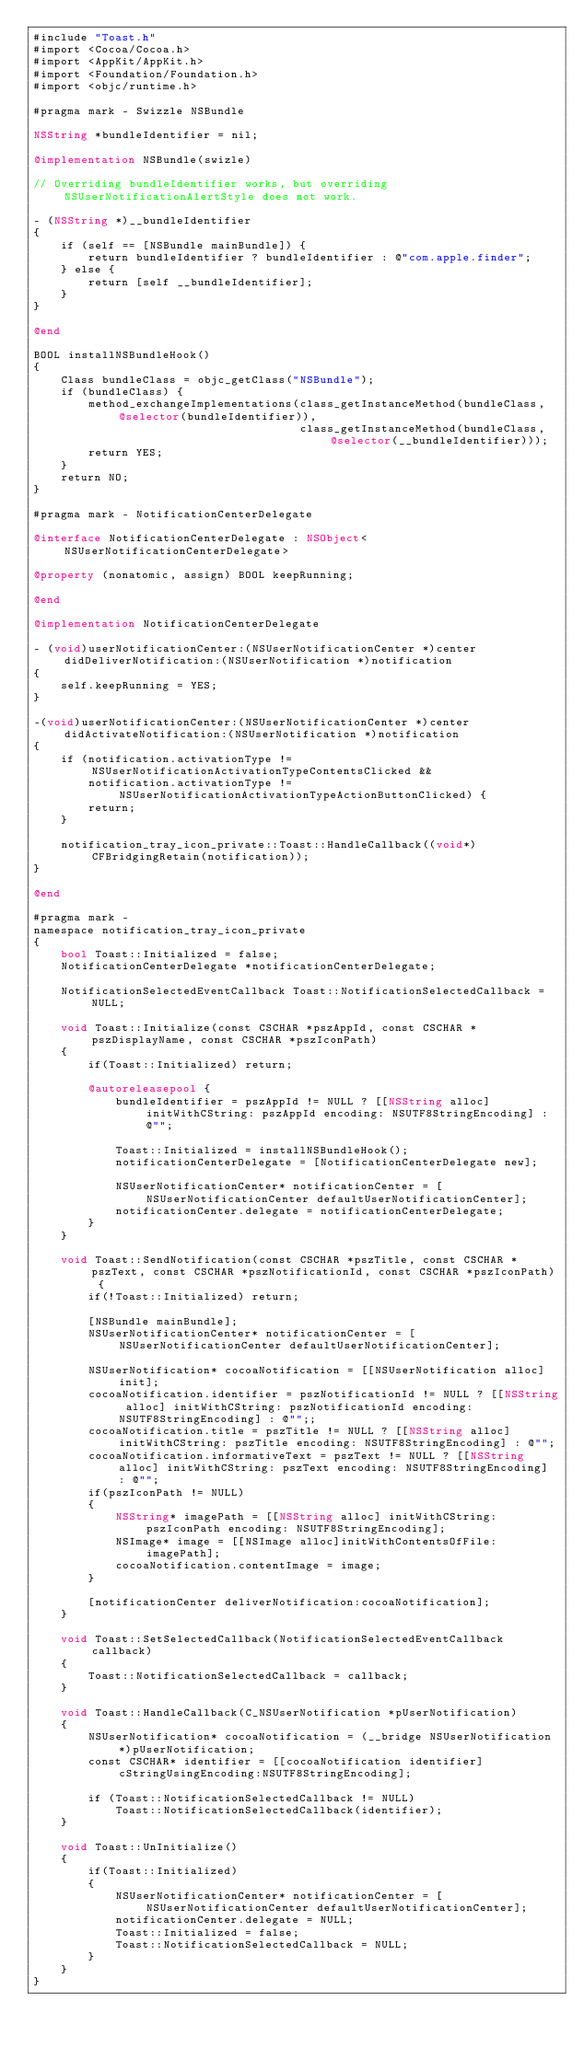Convert code to text. <code><loc_0><loc_0><loc_500><loc_500><_ObjectiveC_>#include "Toast.h"
#import <Cocoa/Cocoa.h>
#import <AppKit/AppKit.h>
#import <Foundation/Foundation.h>
#import <objc/runtime.h>

#pragma mark - Swizzle NSBundle

NSString *bundleIdentifier = nil; 

@implementation NSBundle(swizle)

// Overriding bundleIdentifier works, but overriding NSUserNotificationAlertStyle does not work.

- (NSString *)__bundleIdentifier
{
    if (self == [NSBundle mainBundle]) {
        return bundleIdentifier ? bundleIdentifier : @"com.apple.finder";
    } else {
        return [self __bundleIdentifier];
    }
}

@end

BOOL installNSBundleHook()
{
    Class bundleClass = objc_getClass("NSBundle");
    if (bundleClass) {
        method_exchangeImplementations(class_getInstanceMethod(bundleClass, @selector(bundleIdentifier)),
                                       class_getInstanceMethod(bundleClass, @selector(__bundleIdentifier)));
        return YES;
    }
    return NO;
}

#pragma mark - NotificationCenterDelegate

@interface NotificationCenterDelegate : NSObject<NSUserNotificationCenterDelegate>

@property (nonatomic, assign) BOOL keepRunning;

@end

@implementation NotificationCenterDelegate

- (void)userNotificationCenter:(NSUserNotificationCenter *)center didDeliverNotification:(NSUserNotification *)notification
{
    self.keepRunning = YES;
}

-(void)userNotificationCenter:(NSUserNotificationCenter *)center didActivateNotification:(NSUserNotification *)notification
{
    if (notification.activationType != NSUserNotificationActivationTypeContentsClicked &&
        notification.activationType != NSUserNotificationActivationTypeActionButtonClicked) {
        return;
    }

    notification_tray_icon_private::Toast::HandleCallback((void*)CFBridgingRetain(notification));
}

@end

#pragma mark -
namespace notification_tray_icon_private
{
    bool Toast::Initialized = false;
    NotificationCenterDelegate *notificationCenterDelegate;

    NotificationSelectedEventCallback Toast::NotificationSelectedCallback = NULL;

    void Toast::Initialize(const CSCHAR *pszAppId, const CSCHAR *pszDisplayName, const CSCHAR *pszIconPath)
    {
        if(Toast::Initialized) return;

        @autoreleasepool {
            bundleIdentifier = pszAppId != NULL ? [[NSString alloc] initWithCString: pszAppId encoding: NSUTF8StringEncoding] : @"";

            Toast::Initialized = installNSBundleHook();
            notificationCenterDelegate = [NotificationCenterDelegate new];

            NSUserNotificationCenter* notificationCenter = [NSUserNotificationCenter defaultUserNotificationCenter];
            notificationCenter.delegate = notificationCenterDelegate;
        }
    }

    void Toast::SendNotification(const CSCHAR *pszTitle, const CSCHAR *pszText, const CSCHAR *pszNotificationId, const CSCHAR *pszIconPath) {
        if(!Toast::Initialized) return;

        [NSBundle mainBundle];
        NSUserNotificationCenter* notificationCenter = [NSUserNotificationCenter defaultUserNotificationCenter];

        NSUserNotification* cocoaNotification = [[NSUserNotification alloc] init];
        cocoaNotification.identifier = pszNotificationId != NULL ? [[NSString alloc] initWithCString: pszNotificationId encoding: NSUTF8StringEncoding] : @"";;
        cocoaNotification.title = pszTitle != NULL ? [[NSString alloc] initWithCString: pszTitle encoding: NSUTF8StringEncoding] : @"";
        cocoaNotification.informativeText = pszText != NULL ? [[NSString alloc] initWithCString: pszText encoding: NSUTF8StringEncoding] : @"";
        if(pszIconPath != NULL)
        {
            NSString* imagePath = [[NSString alloc] initWithCString: pszIconPath encoding: NSUTF8StringEncoding];
            NSImage* image = [[NSImage alloc]initWithContentsOfFile: imagePath];
            cocoaNotification.contentImage = image;
        }

        [notificationCenter deliverNotification:cocoaNotification];
    }

    void Toast::SetSelectedCallback(NotificationSelectedEventCallback callback)
    {
        Toast::NotificationSelectedCallback = callback;
    }

    void Toast::HandleCallback(C_NSUserNotification *pUserNotification)
    {
        NSUserNotification* cocoaNotification = (__bridge NSUserNotification*)pUserNotification;
        const CSCHAR* identifier = [[cocoaNotification identifier] cStringUsingEncoding:NSUTF8StringEncoding];
        
        if (Toast::NotificationSelectedCallback != NULL)
            Toast::NotificationSelectedCallback(identifier);
    }

    void Toast::UnInitialize()
    {
        if(Toast::Initialized)
        {
            NSUserNotificationCenter* notificationCenter = [NSUserNotificationCenter defaultUserNotificationCenter];
            notificationCenter.delegate = NULL;
            Toast::Initialized = false;
            Toast::NotificationSelectedCallback = NULL;
        }
    }
}
</code> 